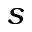Convert formula to latex. <formula><loc_0><loc_0><loc_500><loc_500>s</formula> 